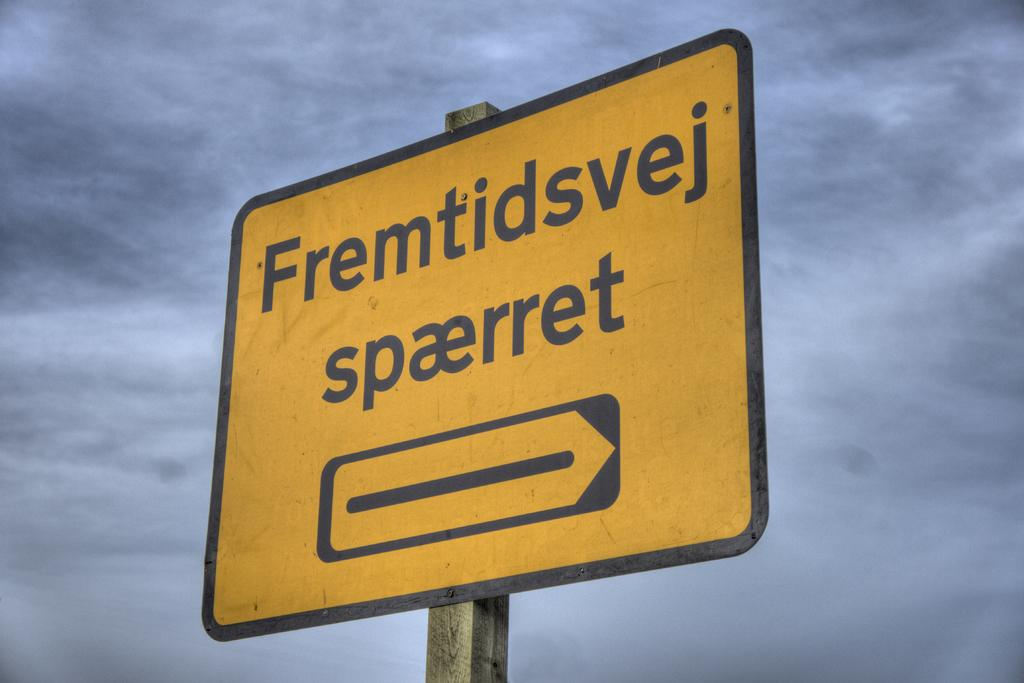<image>
Offer a succinct explanation of the picture presented. a sign that is yellow that says spaerret on the bottom 